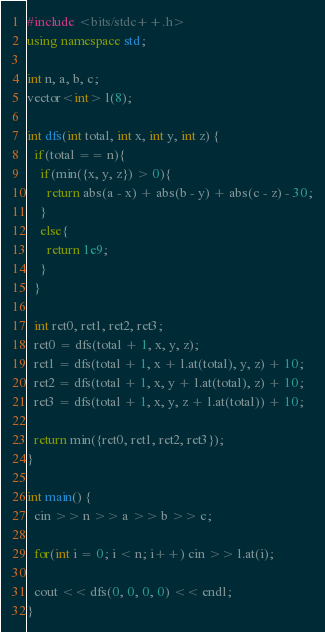<code> <loc_0><loc_0><loc_500><loc_500><_C++_>#include <bits/stdc++.h>
using namespace std;

int n, a, b, c;
vector<int> l(8);

int dfs(int total, int x, int y, int z) {
  if(total == n){
    if(min({x, y, z}) > 0){
      return abs(a - x) + abs(b - y) + abs(c - z) - 30;
    }
    else{
      return 1e9;
    }
  }
  
  int ret0, ret1, ret2, ret3;
  ret0 = dfs(total + 1, x, y, z);
  ret1 = dfs(total + 1, x + l.at(total), y, z) + 10;
  ret2 = dfs(total + 1, x, y + l.at(total), z) + 10;
  ret3 = dfs(total + 1, x, y, z + l.at(total)) + 10;
  
  return min({ret0, ret1, ret2, ret3});
}

int main() {
  cin >> n >> a >> b >> c;
  
  for(int i = 0; i < n; i++) cin >> l.at(i);
  
  cout << dfs(0, 0, 0, 0) << endl;
}</code> 